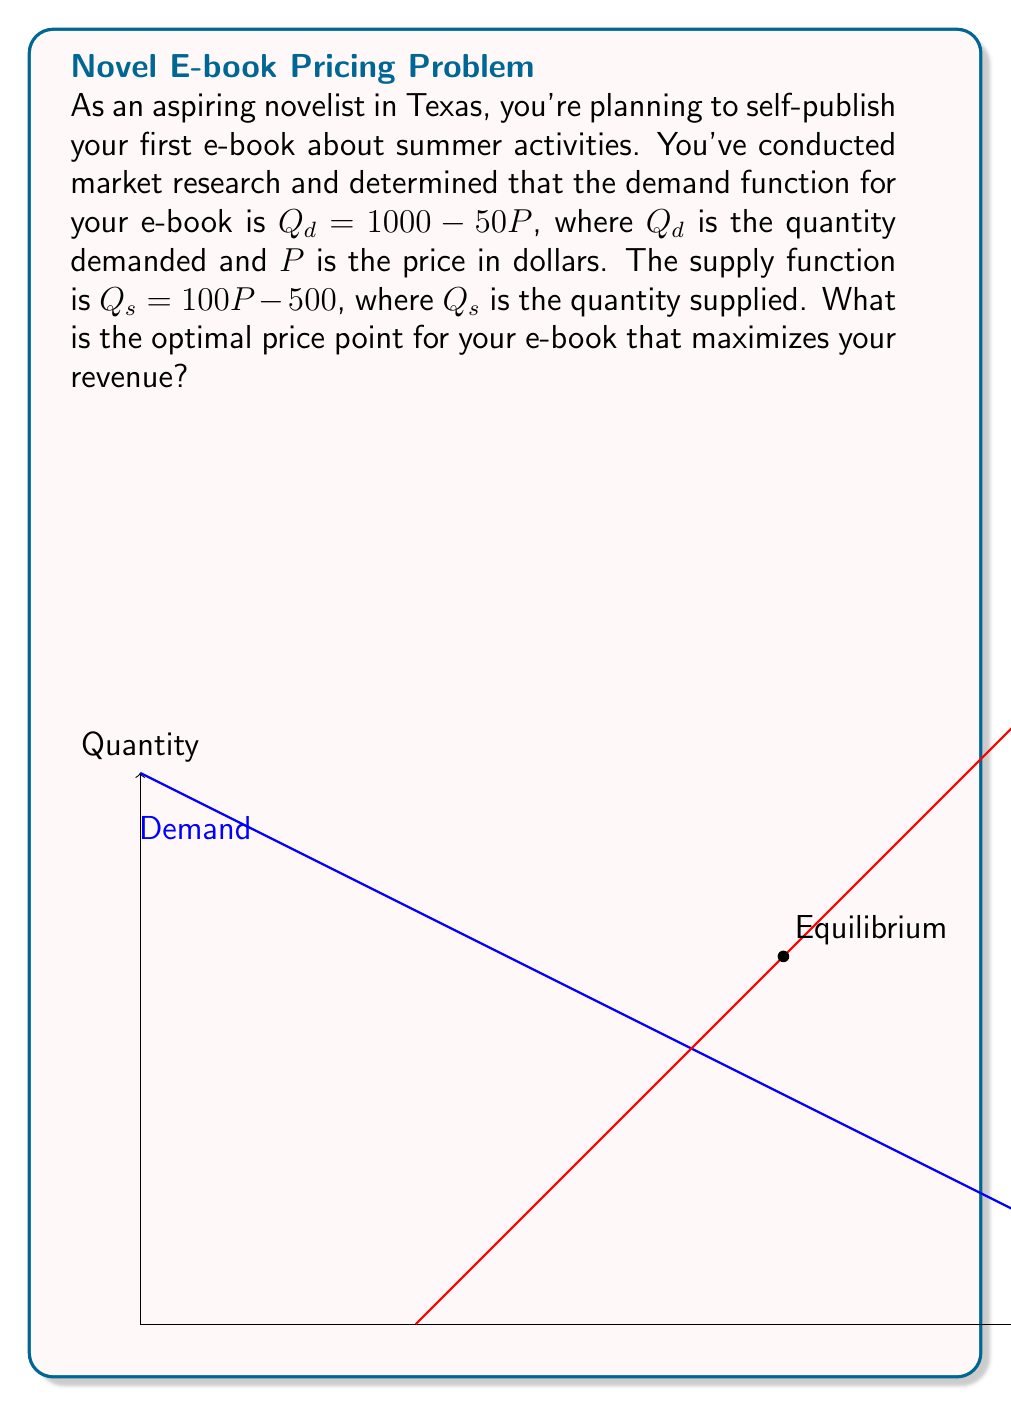Teach me how to tackle this problem. Let's approach this step-by-step:

1) First, we need to find the equilibrium point where supply equals demand:

   $Q_d = Q_s$
   $1000 - 50P = 100P - 500$
   $1500 = 150P$
   $P = 10$

2) At $P = 10$, $Q = 500$. This is the equilibrium point.

3) However, to maximize revenue, we need to find the price where marginal revenue equals zero.

4) The revenue function is $R = P \cdot Q_d = P(1000 - 50P) = 1000P - 50P^2$

5) The marginal revenue function is the derivative of the revenue function:

   $MR = \frac{dR}{dP} = 1000 - 100P$

6) Set $MR = 0$ and solve for $P$:

   $1000 - 100P = 0$
   $1000 = 100P$
   $P = 10$

7) To confirm this is a maximum, we can check the second derivative:

   $\frac{d^2R}{dP^2} = -100 < 0$, confirming a maximum.

8) At $P = 10$, $Q = 1000 - 50(10) = 500$

Therefore, the optimal price point that maximizes revenue is $10.
Answer: $10 